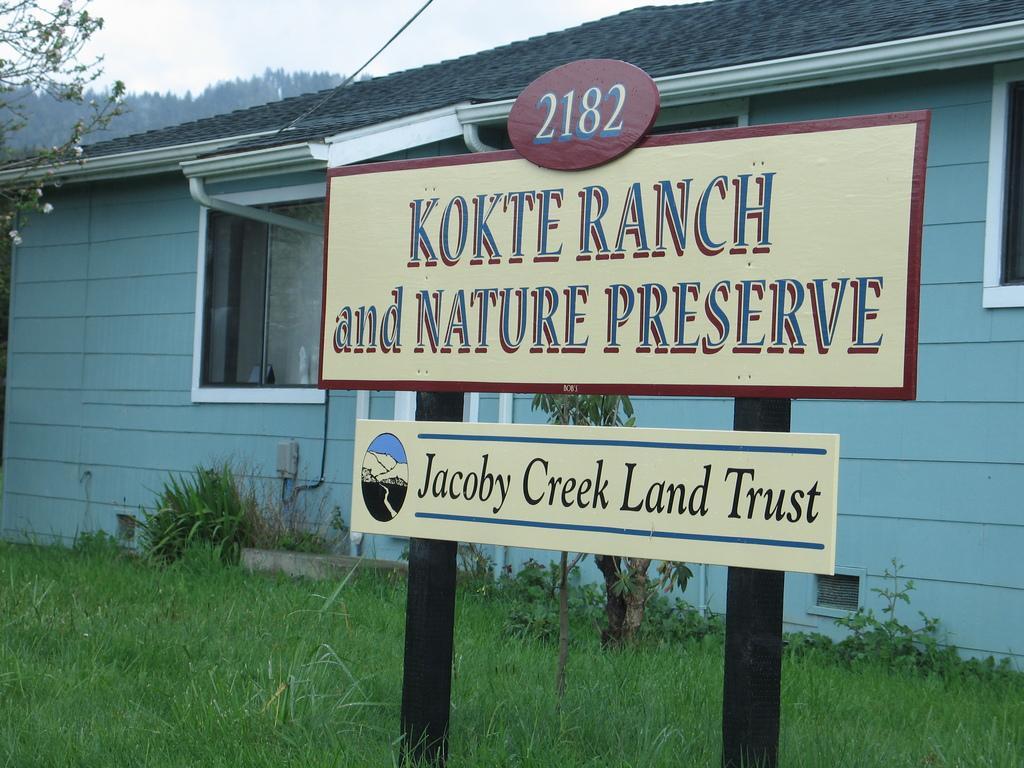Describe this image in one or two sentences. In this image I can see a board and something is written on it. It is in cream,blue and maroon color. Back Side I can see a house and glass window. We can see a trees and green grass. The sky is in white color. 